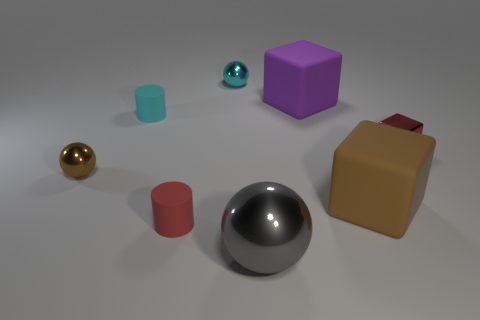Is the number of purple matte objects in front of the large gray metallic thing the same as the number of blue metallic cubes?
Provide a short and direct response. Yes. How many objects are either purple objects or rubber cubes in front of the small red shiny thing?
Offer a terse response. 2. Are there any tiny rubber objects that have the same shape as the tiny cyan metallic object?
Your response must be concise. No. Are there an equal number of brown spheres that are behind the small cyan matte cylinder and things behind the big purple rubber thing?
Offer a very short reply. No. What number of red things are large rubber blocks or large things?
Provide a short and direct response. 0. What number of cubes have the same size as the cyan matte cylinder?
Your response must be concise. 1. There is a shiny sphere that is behind the brown rubber block and in front of the cyan matte cylinder; what is its color?
Ensure brevity in your answer.  Brown. Are there more tiny brown objects right of the cyan rubber thing than red things?
Your answer should be very brief. No. Is there a tiny blue cube?
Provide a succinct answer. No. Is the color of the metal cube the same as the big shiny sphere?
Your answer should be very brief. No. 